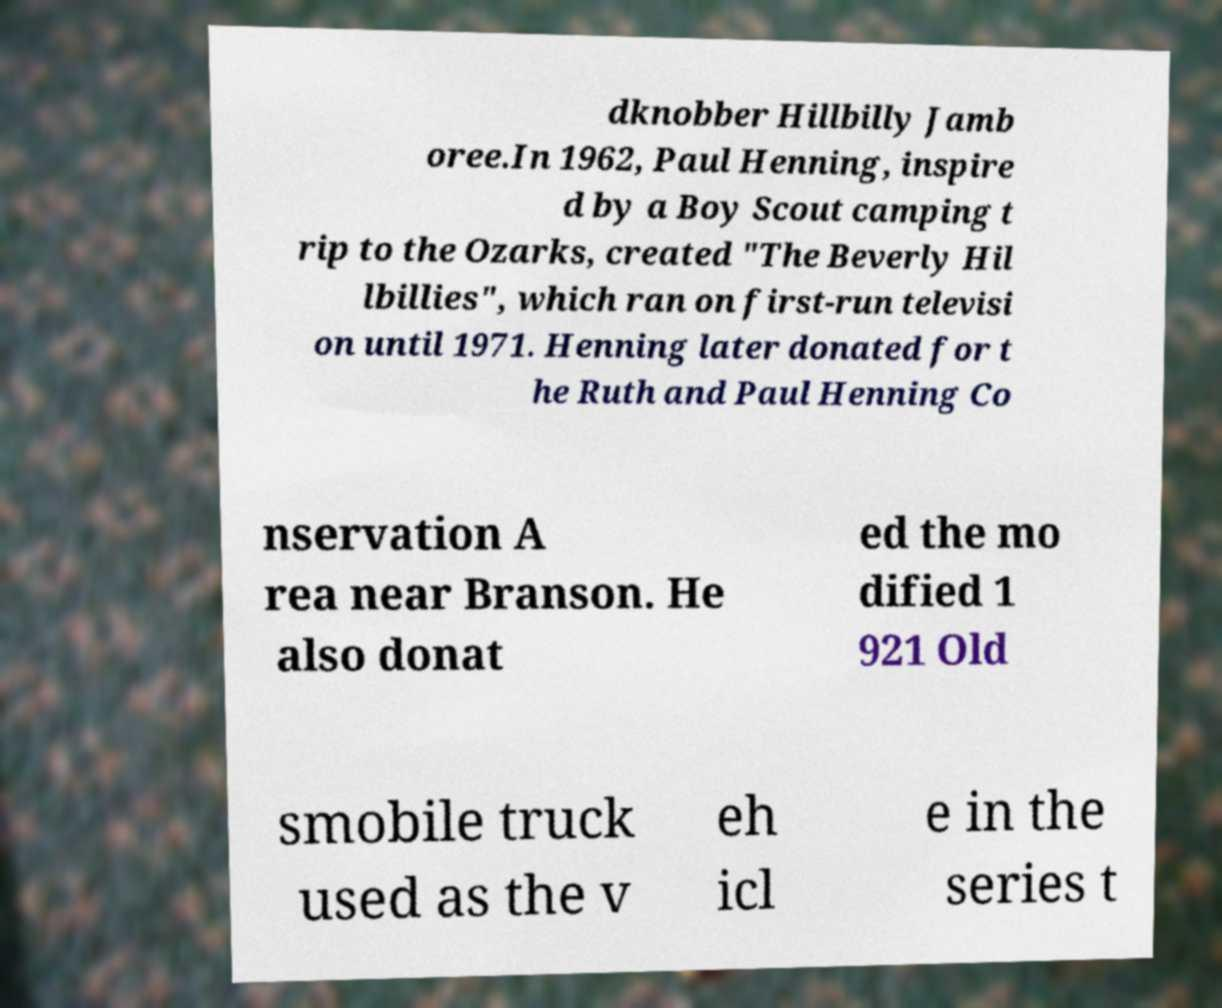Please read and relay the text visible in this image. What does it say? dknobber Hillbilly Jamb oree.In 1962, Paul Henning, inspire d by a Boy Scout camping t rip to the Ozarks, created "The Beverly Hil lbillies", which ran on first-run televisi on until 1971. Henning later donated for t he Ruth and Paul Henning Co nservation A rea near Branson. He also donat ed the mo dified 1 921 Old smobile truck used as the v eh icl e in the series t 